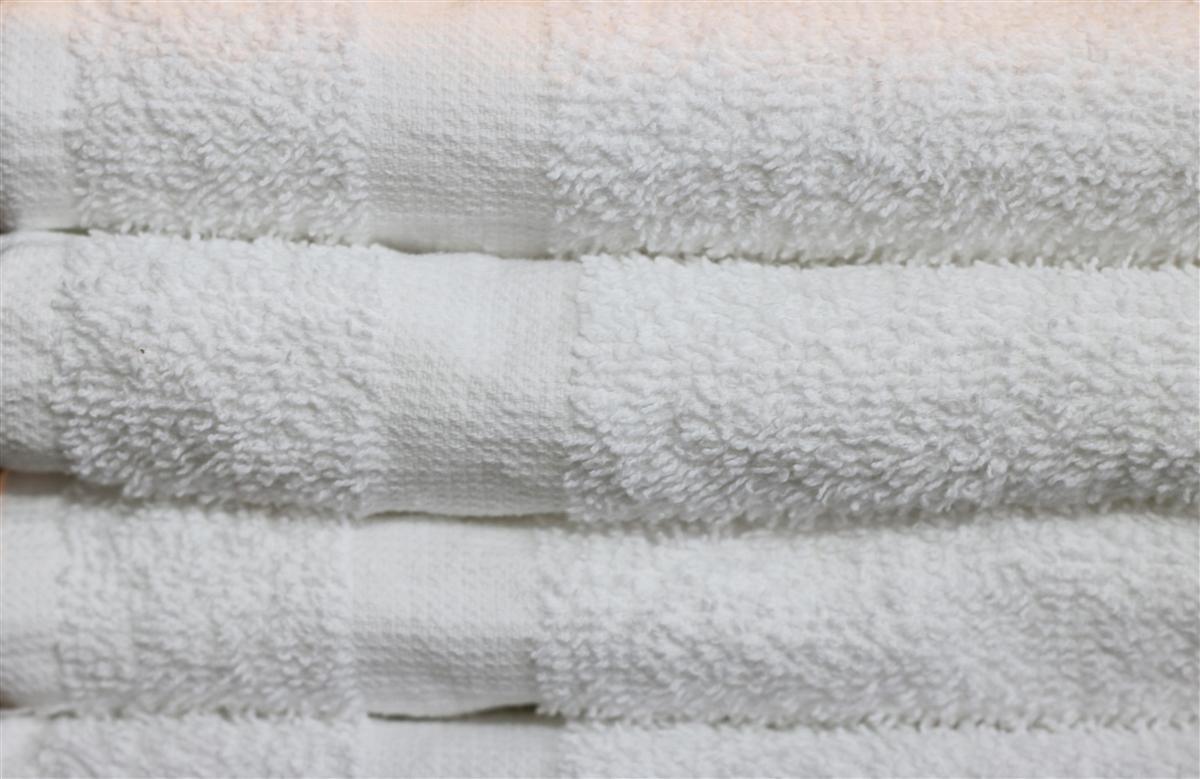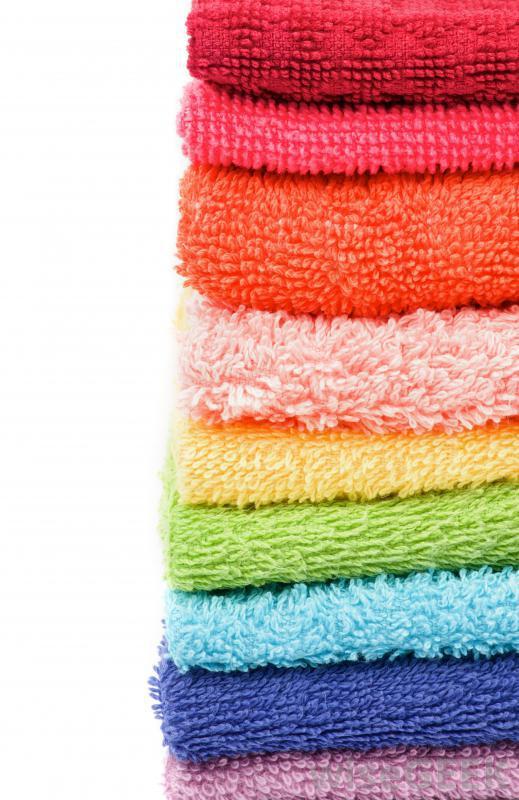The first image is the image on the left, the second image is the image on the right. Considering the images on both sides, is "There are multiple colors of towels in the right image." valid? Answer yes or no. Yes. 